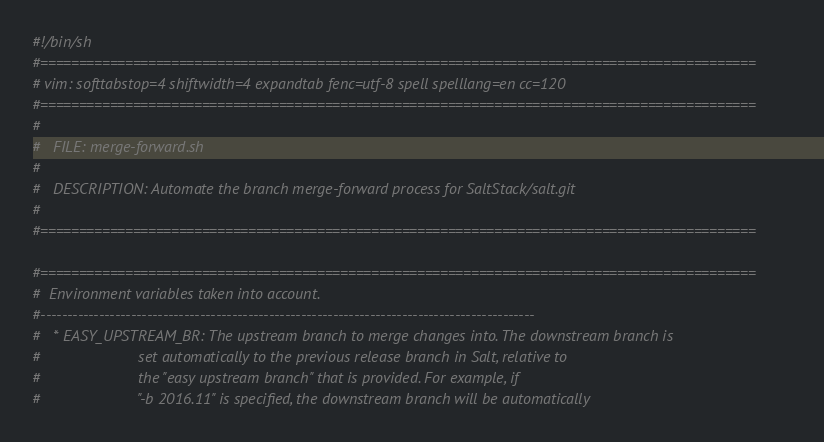<code> <loc_0><loc_0><loc_500><loc_500><_Bash_>#!/bin/sh
#=============================================================================================
# vim: softtabstop=4 shiftwidth=4 expandtab fenc=utf-8 spell spelllang=en cc=120
#=============================================================================================
#
#   FILE: merge-forward.sh
#
#   DESCRIPTION: Automate the branch merge-forward process for SaltStack/salt.git
#
#=============================================================================================

#=============================================================================================
#  Environment variables taken into account.
#---------------------------------------------------------------------------------------------
#   * EASY_UPSTREAM_BR: The upstream branch to merge changes into. The downstream branch is
#                       set automatically to the previous release branch in Salt, relative to
#                       the "easy upstream branch" that is provided. For example, if
#                       "-b 2016.11" is specified, the downstream branch will be automatically</code> 